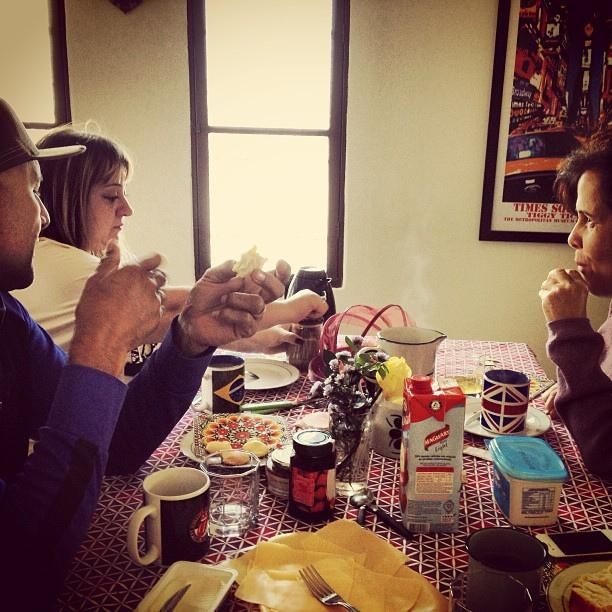Why have these people gathered? Please explain your reasoning. to eat. The people are eating. 